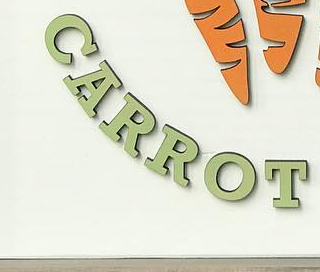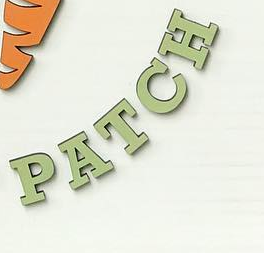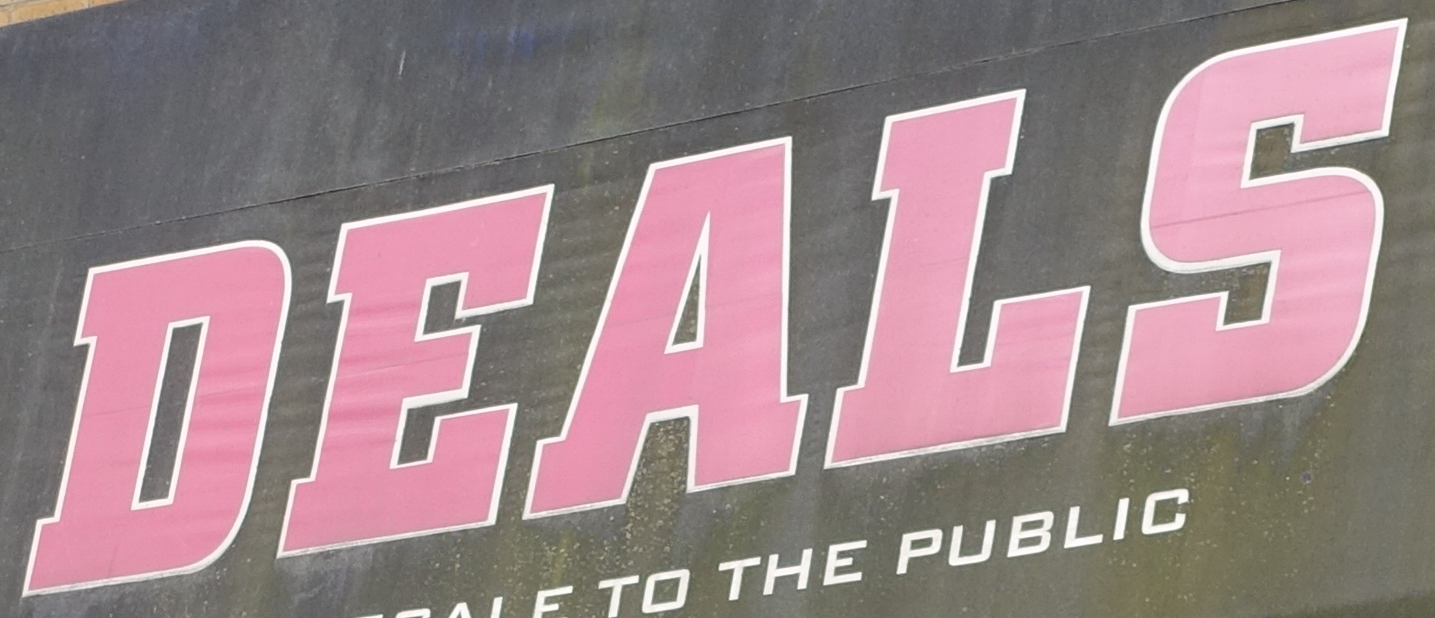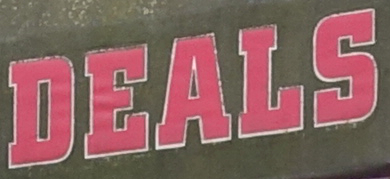Identify the words shown in these images in order, separated by a semicolon. CARROT; PATCH; DEALS; DEALS 